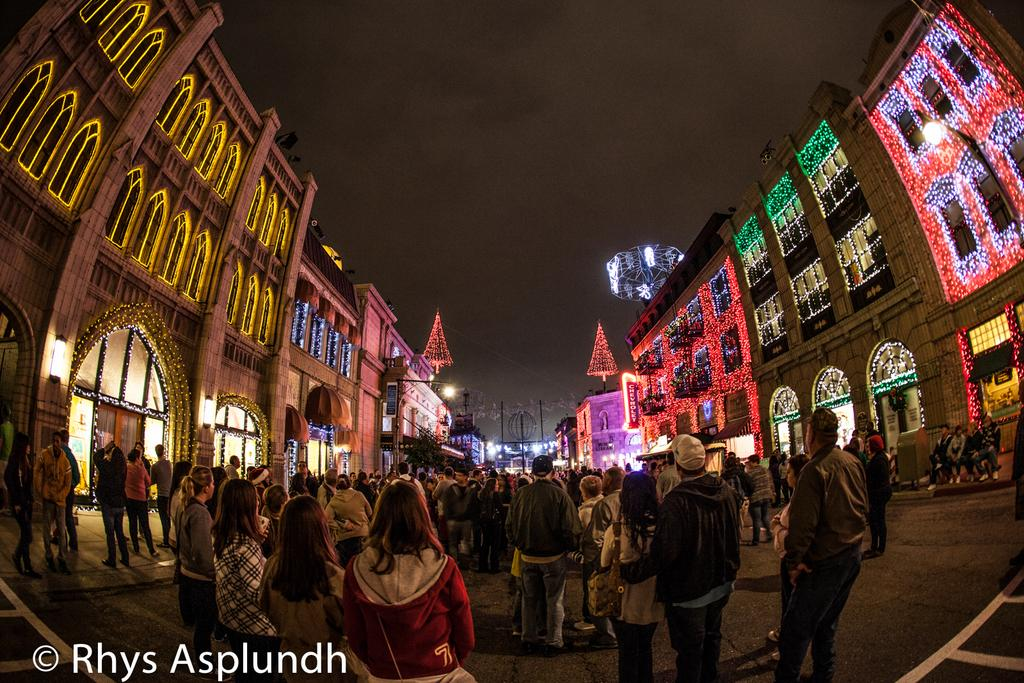What is happening with the group of people in the image? The group of people is on the ground. What can be seen in the background of the image? There are buildings, lights, poles, and the sky visible in the background of the image. Can you describe the text in the bottom left of the image? There is some text in the bottom left of the image. What type of spacecraft can be seen in the image? There is no spacecraft present in the image. What angle is the image taken from? The angle from which the image is taken cannot be determined from the image itself. 